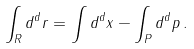<formula> <loc_0><loc_0><loc_500><loc_500>\int _ { R } d ^ { d } r = \int d ^ { d } x - \int _ { P } d ^ { d } p \, .</formula> 